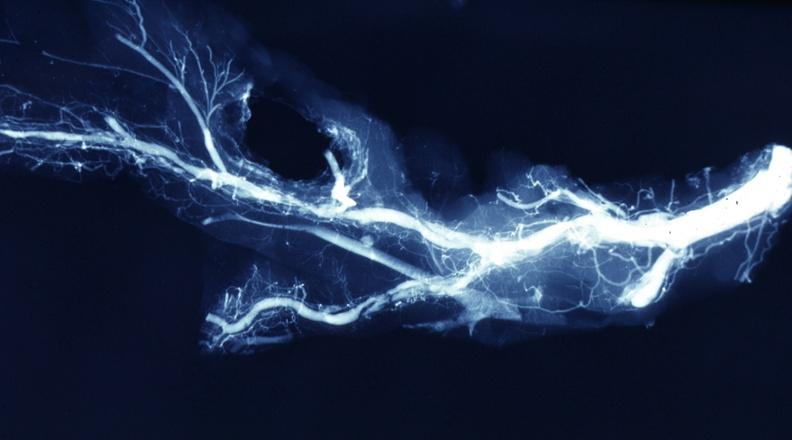how is x-ray postmortdissected artery lesions in branches?
Answer the question using a single word or phrase. Small 